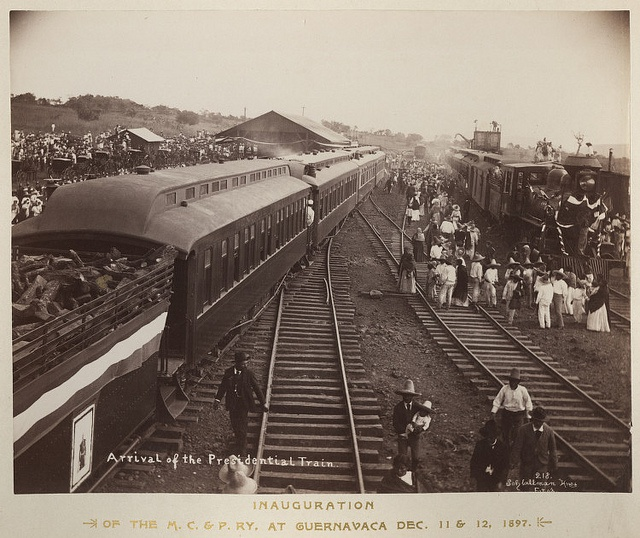Describe the objects in this image and their specific colors. I can see train in lightgray, black, gray, and darkgray tones, people in lightgray, gray, black, and darkgray tones, train in lightgray, black, gray, and maroon tones, people in lightgray, black, and gray tones, and people in lightgray, black, gray, and maroon tones in this image. 